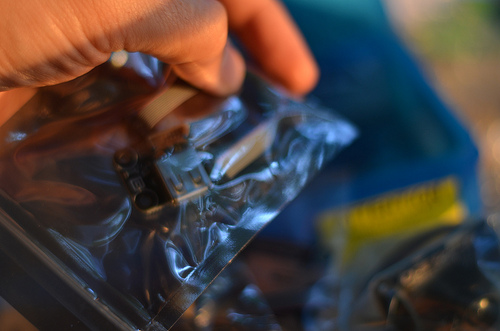<image>
Is there a card next to the plastic? No. The card is not positioned next to the plastic. They are located in different areas of the scene. 